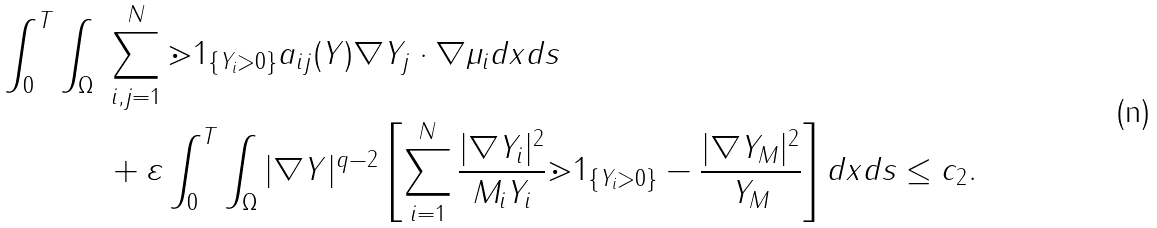<formula> <loc_0><loc_0><loc_500><loc_500>\int _ { 0 } ^ { T } \int _ { \Omega } \ & \sum ^ { N } _ { i , j = 1 } \mathbb { m } { 1 } _ { \left \{ Y _ { i } > 0 \right \} } a _ { i j } ( Y ) \nabla Y _ { j } \cdot \nabla \mu _ { i } d x d s \\ & + \varepsilon \int _ { 0 } ^ { T } \int _ { \Omega } | \nabla Y | ^ { q - 2 } \left [ \sum ^ { N } _ { i = 1 } \frac { | \nabla Y _ { i } | ^ { 2 } } { M _ { i } Y _ { i } } \mathbb { m } { 1 } _ { \left \{ Y _ { i } > 0 \right \} } - \frac { | \nabla Y _ { M } | ^ { 2 } } { Y _ { M } } \right ] d x d s \leq c _ { 2 } .</formula> 